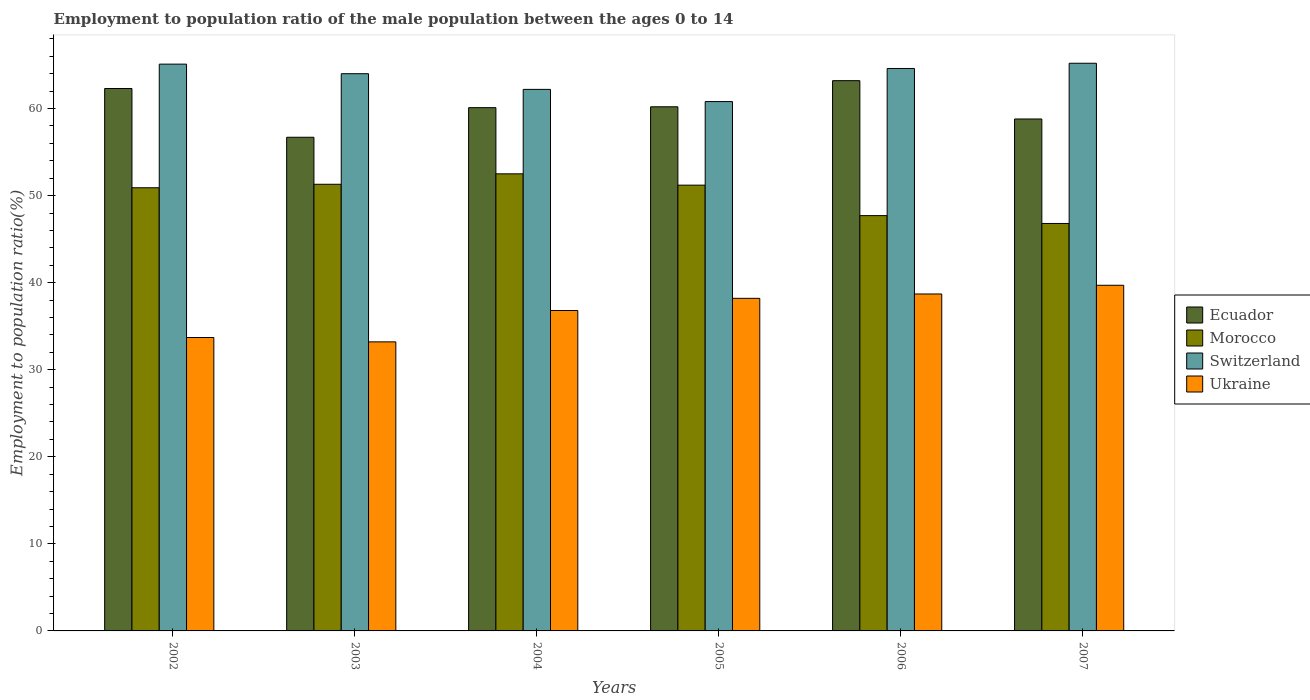How many different coloured bars are there?
Provide a succinct answer. 4. In how many cases, is the number of bars for a given year not equal to the number of legend labels?
Keep it short and to the point. 0. What is the employment to population ratio in Ecuador in 2005?
Keep it short and to the point. 60.2. Across all years, what is the maximum employment to population ratio in Morocco?
Your answer should be very brief. 52.5. Across all years, what is the minimum employment to population ratio in Morocco?
Ensure brevity in your answer.  46.8. In which year was the employment to population ratio in Ecuador maximum?
Offer a terse response. 2006. In which year was the employment to population ratio in Morocco minimum?
Ensure brevity in your answer.  2007. What is the total employment to population ratio in Switzerland in the graph?
Offer a very short reply. 381.9. What is the difference between the employment to population ratio in Switzerland in 2005 and that in 2007?
Make the answer very short. -4.4. What is the difference between the employment to population ratio in Ukraine in 2007 and the employment to population ratio in Switzerland in 2003?
Provide a short and direct response. -24.3. What is the average employment to population ratio in Morocco per year?
Give a very brief answer. 50.07. In the year 2003, what is the difference between the employment to population ratio in Ukraine and employment to population ratio in Morocco?
Your answer should be very brief. -18.1. In how many years, is the employment to population ratio in Switzerland greater than 18 %?
Offer a very short reply. 6. What is the ratio of the employment to population ratio in Switzerland in 2003 to that in 2006?
Keep it short and to the point. 0.99. Is the employment to population ratio in Morocco in 2002 less than that in 2006?
Make the answer very short. No. What is the difference between the highest and the second highest employment to population ratio in Ecuador?
Give a very brief answer. 0.9. What is the difference between the highest and the lowest employment to population ratio in Switzerland?
Ensure brevity in your answer.  4.4. Is the sum of the employment to population ratio in Morocco in 2003 and 2004 greater than the maximum employment to population ratio in Ukraine across all years?
Keep it short and to the point. Yes. What does the 3rd bar from the left in 2006 represents?
Make the answer very short. Switzerland. What does the 3rd bar from the right in 2003 represents?
Offer a terse response. Morocco. Is it the case that in every year, the sum of the employment to population ratio in Morocco and employment to population ratio in Ecuador is greater than the employment to population ratio in Switzerland?
Keep it short and to the point. Yes. What is the difference between two consecutive major ticks on the Y-axis?
Make the answer very short. 10. Are the values on the major ticks of Y-axis written in scientific E-notation?
Provide a succinct answer. No. Does the graph contain grids?
Offer a very short reply. No. Where does the legend appear in the graph?
Keep it short and to the point. Center right. How many legend labels are there?
Offer a terse response. 4. What is the title of the graph?
Give a very brief answer. Employment to population ratio of the male population between the ages 0 to 14. What is the label or title of the X-axis?
Offer a terse response. Years. What is the label or title of the Y-axis?
Your response must be concise. Employment to population ratio(%). What is the Employment to population ratio(%) of Ecuador in 2002?
Your answer should be compact. 62.3. What is the Employment to population ratio(%) of Morocco in 2002?
Offer a very short reply. 50.9. What is the Employment to population ratio(%) of Switzerland in 2002?
Provide a succinct answer. 65.1. What is the Employment to population ratio(%) in Ukraine in 2002?
Offer a terse response. 33.7. What is the Employment to population ratio(%) of Ecuador in 2003?
Provide a short and direct response. 56.7. What is the Employment to population ratio(%) in Morocco in 2003?
Make the answer very short. 51.3. What is the Employment to population ratio(%) in Ukraine in 2003?
Give a very brief answer. 33.2. What is the Employment to population ratio(%) in Ecuador in 2004?
Your answer should be compact. 60.1. What is the Employment to population ratio(%) in Morocco in 2004?
Your answer should be very brief. 52.5. What is the Employment to population ratio(%) in Switzerland in 2004?
Provide a succinct answer. 62.2. What is the Employment to population ratio(%) of Ukraine in 2004?
Give a very brief answer. 36.8. What is the Employment to population ratio(%) of Ecuador in 2005?
Provide a short and direct response. 60.2. What is the Employment to population ratio(%) in Morocco in 2005?
Your response must be concise. 51.2. What is the Employment to population ratio(%) of Switzerland in 2005?
Ensure brevity in your answer.  60.8. What is the Employment to population ratio(%) in Ukraine in 2005?
Your answer should be very brief. 38.2. What is the Employment to population ratio(%) of Ecuador in 2006?
Keep it short and to the point. 63.2. What is the Employment to population ratio(%) of Morocco in 2006?
Ensure brevity in your answer.  47.7. What is the Employment to population ratio(%) of Switzerland in 2006?
Give a very brief answer. 64.6. What is the Employment to population ratio(%) in Ukraine in 2006?
Give a very brief answer. 38.7. What is the Employment to population ratio(%) of Ecuador in 2007?
Make the answer very short. 58.8. What is the Employment to population ratio(%) in Morocco in 2007?
Offer a very short reply. 46.8. What is the Employment to population ratio(%) of Switzerland in 2007?
Your answer should be very brief. 65.2. What is the Employment to population ratio(%) in Ukraine in 2007?
Give a very brief answer. 39.7. Across all years, what is the maximum Employment to population ratio(%) of Ecuador?
Provide a succinct answer. 63.2. Across all years, what is the maximum Employment to population ratio(%) of Morocco?
Offer a very short reply. 52.5. Across all years, what is the maximum Employment to population ratio(%) of Switzerland?
Your response must be concise. 65.2. Across all years, what is the maximum Employment to population ratio(%) of Ukraine?
Offer a terse response. 39.7. Across all years, what is the minimum Employment to population ratio(%) in Ecuador?
Provide a succinct answer. 56.7. Across all years, what is the minimum Employment to population ratio(%) in Morocco?
Ensure brevity in your answer.  46.8. Across all years, what is the minimum Employment to population ratio(%) of Switzerland?
Offer a terse response. 60.8. Across all years, what is the minimum Employment to population ratio(%) of Ukraine?
Keep it short and to the point. 33.2. What is the total Employment to population ratio(%) in Ecuador in the graph?
Give a very brief answer. 361.3. What is the total Employment to population ratio(%) in Morocco in the graph?
Offer a very short reply. 300.4. What is the total Employment to population ratio(%) of Switzerland in the graph?
Give a very brief answer. 381.9. What is the total Employment to population ratio(%) in Ukraine in the graph?
Keep it short and to the point. 220.3. What is the difference between the Employment to population ratio(%) in Ecuador in 2002 and that in 2003?
Offer a terse response. 5.6. What is the difference between the Employment to population ratio(%) of Switzerland in 2002 and that in 2003?
Give a very brief answer. 1.1. What is the difference between the Employment to population ratio(%) in Ukraine in 2002 and that in 2003?
Your response must be concise. 0.5. What is the difference between the Employment to population ratio(%) of Ecuador in 2002 and that in 2004?
Give a very brief answer. 2.2. What is the difference between the Employment to population ratio(%) of Morocco in 2002 and that in 2004?
Offer a terse response. -1.6. What is the difference between the Employment to population ratio(%) of Switzerland in 2002 and that in 2004?
Keep it short and to the point. 2.9. What is the difference between the Employment to population ratio(%) in Ecuador in 2002 and that in 2005?
Provide a short and direct response. 2.1. What is the difference between the Employment to population ratio(%) in Ukraine in 2002 and that in 2005?
Your answer should be compact. -4.5. What is the difference between the Employment to population ratio(%) of Ecuador in 2002 and that in 2006?
Your answer should be compact. -0.9. What is the difference between the Employment to population ratio(%) of Ecuador in 2002 and that in 2007?
Provide a short and direct response. 3.5. What is the difference between the Employment to population ratio(%) in Morocco in 2002 and that in 2007?
Give a very brief answer. 4.1. What is the difference between the Employment to population ratio(%) in Ukraine in 2002 and that in 2007?
Keep it short and to the point. -6. What is the difference between the Employment to population ratio(%) of Ecuador in 2003 and that in 2004?
Offer a very short reply. -3.4. What is the difference between the Employment to population ratio(%) of Switzerland in 2003 and that in 2005?
Offer a very short reply. 3.2. What is the difference between the Employment to population ratio(%) of Switzerland in 2003 and that in 2006?
Give a very brief answer. -0.6. What is the difference between the Employment to population ratio(%) of Ecuador in 2003 and that in 2007?
Your answer should be very brief. -2.1. What is the difference between the Employment to population ratio(%) in Ukraine in 2004 and that in 2005?
Ensure brevity in your answer.  -1.4. What is the difference between the Employment to population ratio(%) of Ecuador in 2004 and that in 2006?
Provide a short and direct response. -3.1. What is the difference between the Employment to population ratio(%) of Morocco in 2004 and that in 2006?
Provide a succinct answer. 4.8. What is the difference between the Employment to population ratio(%) in Switzerland in 2004 and that in 2006?
Offer a terse response. -2.4. What is the difference between the Employment to population ratio(%) in Morocco in 2004 and that in 2007?
Your answer should be compact. 5.7. What is the difference between the Employment to population ratio(%) in Morocco in 2005 and that in 2006?
Your answer should be very brief. 3.5. What is the difference between the Employment to population ratio(%) of Ukraine in 2005 and that in 2006?
Offer a very short reply. -0.5. What is the difference between the Employment to population ratio(%) of Ecuador in 2005 and that in 2007?
Ensure brevity in your answer.  1.4. What is the difference between the Employment to population ratio(%) of Ukraine in 2005 and that in 2007?
Ensure brevity in your answer.  -1.5. What is the difference between the Employment to population ratio(%) of Ecuador in 2006 and that in 2007?
Ensure brevity in your answer.  4.4. What is the difference between the Employment to population ratio(%) of Morocco in 2006 and that in 2007?
Your answer should be very brief. 0.9. What is the difference between the Employment to population ratio(%) of Ecuador in 2002 and the Employment to population ratio(%) of Morocco in 2003?
Keep it short and to the point. 11. What is the difference between the Employment to population ratio(%) in Ecuador in 2002 and the Employment to population ratio(%) in Ukraine in 2003?
Your answer should be compact. 29.1. What is the difference between the Employment to population ratio(%) in Morocco in 2002 and the Employment to population ratio(%) in Ukraine in 2003?
Give a very brief answer. 17.7. What is the difference between the Employment to population ratio(%) of Switzerland in 2002 and the Employment to population ratio(%) of Ukraine in 2003?
Your answer should be very brief. 31.9. What is the difference between the Employment to population ratio(%) in Ecuador in 2002 and the Employment to population ratio(%) in Switzerland in 2004?
Provide a succinct answer. 0.1. What is the difference between the Employment to population ratio(%) in Ecuador in 2002 and the Employment to population ratio(%) in Ukraine in 2004?
Provide a succinct answer. 25.5. What is the difference between the Employment to population ratio(%) of Morocco in 2002 and the Employment to population ratio(%) of Ukraine in 2004?
Make the answer very short. 14.1. What is the difference between the Employment to population ratio(%) of Switzerland in 2002 and the Employment to population ratio(%) of Ukraine in 2004?
Provide a short and direct response. 28.3. What is the difference between the Employment to population ratio(%) in Ecuador in 2002 and the Employment to population ratio(%) in Switzerland in 2005?
Your answer should be very brief. 1.5. What is the difference between the Employment to population ratio(%) of Ecuador in 2002 and the Employment to population ratio(%) of Ukraine in 2005?
Keep it short and to the point. 24.1. What is the difference between the Employment to population ratio(%) of Morocco in 2002 and the Employment to population ratio(%) of Switzerland in 2005?
Ensure brevity in your answer.  -9.9. What is the difference between the Employment to population ratio(%) of Morocco in 2002 and the Employment to population ratio(%) of Ukraine in 2005?
Your answer should be compact. 12.7. What is the difference between the Employment to population ratio(%) in Switzerland in 2002 and the Employment to population ratio(%) in Ukraine in 2005?
Give a very brief answer. 26.9. What is the difference between the Employment to population ratio(%) in Ecuador in 2002 and the Employment to population ratio(%) in Switzerland in 2006?
Make the answer very short. -2.3. What is the difference between the Employment to population ratio(%) of Ecuador in 2002 and the Employment to population ratio(%) of Ukraine in 2006?
Offer a very short reply. 23.6. What is the difference between the Employment to population ratio(%) in Morocco in 2002 and the Employment to population ratio(%) in Switzerland in 2006?
Ensure brevity in your answer.  -13.7. What is the difference between the Employment to population ratio(%) of Switzerland in 2002 and the Employment to population ratio(%) of Ukraine in 2006?
Offer a terse response. 26.4. What is the difference between the Employment to population ratio(%) of Ecuador in 2002 and the Employment to population ratio(%) of Switzerland in 2007?
Your answer should be compact. -2.9. What is the difference between the Employment to population ratio(%) in Ecuador in 2002 and the Employment to population ratio(%) in Ukraine in 2007?
Your answer should be compact. 22.6. What is the difference between the Employment to population ratio(%) of Morocco in 2002 and the Employment to population ratio(%) of Switzerland in 2007?
Your response must be concise. -14.3. What is the difference between the Employment to population ratio(%) in Switzerland in 2002 and the Employment to population ratio(%) in Ukraine in 2007?
Your answer should be very brief. 25.4. What is the difference between the Employment to population ratio(%) of Ecuador in 2003 and the Employment to population ratio(%) of Ukraine in 2004?
Provide a short and direct response. 19.9. What is the difference between the Employment to population ratio(%) of Morocco in 2003 and the Employment to population ratio(%) of Ukraine in 2004?
Keep it short and to the point. 14.5. What is the difference between the Employment to population ratio(%) in Switzerland in 2003 and the Employment to population ratio(%) in Ukraine in 2004?
Provide a succinct answer. 27.2. What is the difference between the Employment to population ratio(%) in Ecuador in 2003 and the Employment to population ratio(%) in Morocco in 2005?
Ensure brevity in your answer.  5.5. What is the difference between the Employment to population ratio(%) of Ecuador in 2003 and the Employment to population ratio(%) of Ukraine in 2005?
Give a very brief answer. 18.5. What is the difference between the Employment to population ratio(%) in Morocco in 2003 and the Employment to population ratio(%) in Switzerland in 2005?
Offer a terse response. -9.5. What is the difference between the Employment to population ratio(%) of Morocco in 2003 and the Employment to population ratio(%) of Ukraine in 2005?
Offer a terse response. 13.1. What is the difference between the Employment to population ratio(%) in Switzerland in 2003 and the Employment to population ratio(%) in Ukraine in 2005?
Your answer should be compact. 25.8. What is the difference between the Employment to population ratio(%) in Ecuador in 2003 and the Employment to population ratio(%) in Switzerland in 2006?
Your answer should be very brief. -7.9. What is the difference between the Employment to population ratio(%) in Ecuador in 2003 and the Employment to population ratio(%) in Ukraine in 2006?
Provide a succinct answer. 18. What is the difference between the Employment to population ratio(%) of Morocco in 2003 and the Employment to population ratio(%) of Switzerland in 2006?
Your answer should be very brief. -13.3. What is the difference between the Employment to population ratio(%) in Switzerland in 2003 and the Employment to population ratio(%) in Ukraine in 2006?
Provide a short and direct response. 25.3. What is the difference between the Employment to population ratio(%) of Morocco in 2003 and the Employment to population ratio(%) of Switzerland in 2007?
Offer a terse response. -13.9. What is the difference between the Employment to population ratio(%) of Switzerland in 2003 and the Employment to population ratio(%) of Ukraine in 2007?
Your answer should be compact. 24.3. What is the difference between the Employment to population ratio(%) in Ecuador in 2004 and the Employment to population ratio(%) in Ukraine in 2005?
Keep it short and to the point. 21.9. What is the difference between the Employment to population ratio(%) of Switzerland in 2004 and the Employment to population ratio(%) of Ukraine in 2005?
Give a very brief answer. 24. What is the difference between the Employment to population ratio(%) of Ecuador in 2004 and the Employment to population ratio(%) of Morocco in 2006?
Make the answer very short. 12.4. What is the difference between the Employment to population ratio(%) in Ecuador in 2004 and the Employment to population ratio(%) in Ukraine in 2006?
Your answer should be very brief. 21.4. What is the difference between the Employment to population ratio(%) of Switzerland in 2004 and the Employment to population ratio(%) of Ukraine in 2006?
Your answer should be very brief. 23.5. What is the difference between the Employment to population ratio(%) in Ecuador in 2004 and the Employment to population ratio(%) in Ukraine in 2007?
Provide a succinct answer. 20.4. What is the difference between the Employment to population ratio(%) of Switzerland in 2004 and the Employment to population ratio(%) of Ukraine in 2007?
Keep it short and to the point. 22.5. What is the difference between the Employment to population ratio(%) of Morocco in 2005 and the Employment to population ratio(%) of Switzerland in 2006?
Your answer should be compact. -13.4. What is the difference between the Employment to population ratio(%) of Morocco in 2005 and the Employment to population ratio(%) of Ukraine in 2006?
Provide a short and direct response. 12.5. What is the difference between the Employment to population ratio(%) in Switzerland in 2005 and the Employment to population ratio(%) in Ukraine in 2006?
Provide a short and direct response. 22.1. What is the difference between the Employment to population ratio(%) in Ecuador in 2005 and the Employment to population ratio(%) in Morocco in 2007?
Your answer should be compact. 13.4. What is the difference between the Employment to population ratio(%) in Ecuador in 2005 and the Employment to population ratio(%) in Switzerland in 2007?
Your answer should be compact. -5. What is the difference between the Employment to population ratio(%) of Morocco in 2005 and the Employment to population ratio(%) of Ukraine in 2007?
Your response must be concise. 11.5. What is the difference between the Employment to population ratio(%) in Switzerland in 2005 and the Employment to population ratio(%) in Ukraine in 2007?
Make the answer very short. 21.1. What is the difference between the Employment to population ratio(%) of Morocco in 2006 and the Employment to population ratio(%) of Switzerland in 2007?
Your answer should be very brief. -17.5. What is the difference between the Employment to population ratio(%) in Morocco in 2006 and the Employment to population ratio(%) in Ukraine in 2007?
Your answer should be very brief. 8. What is the difference between the Employment to population ratio(%) in Switzerland in 2006 and the Employment to population ratio(%) in Ukraine in 2007?
Provide a succinct answer. 24.9. What is the average Employment to population ratio(%) in Ecuador per year?
Offer a very short reply. 60.22. What is the average Employment to population ratio(%) of Morocco per year?
Your response must be concise. 50.07. What is the average Employment to population ratio(%) in Switzerland per year?
Provide a short and direct response. 63.65. What is the average Employment to population ratio(%) in Ukraine per year?
Offer a very short reply. 36.72. In the year 2002, what is the difference between the Employment to population ratio(%) of Ecuador and Employment to population ratio(%) of Switzerland?
Provide a succinct answer. -2.8. In the year 2002, what is the difference between the Employment to population ratio(%) of Ecuador and Employment to population ratio(%) of Ukraine?
Your answer should be compact. 28.6. In the year 2002, what is the difference between the Employment to population ratio(%) of Morocco and Employment to population ratio(%) of Switzerland?
Your answer should be very brief. -14.2. In the year 2002, what is the difference between the Employment to population ratio(%) in Morocco and Employment to population ratio(%) in Ukraine?
Give a very brief answer. 17.2. In the year 2002, what is the difference between the Employment to population ratio(%) of Switzerland and Employment to population ratio(%) of Ukraine?
Your answer should be very brief. 31.4. In the year 2003, what is the difference between the Employment to population ratio(%) in Ecuador and Employment to population ratio(%) in Morocco?
Offer a terse response. 5.4. In the year 2003, what is the difference between the Employment to population ratio(%) in Ecuador and Employment to population ratio(%) in Ukraine?
Provide a short and direct response. 23.5. In the year 2003, what is the difference between the Employment to population ratio(%) in Morocco and Employment to population ratio(%) in Switzerland?
Offer a very short reply. -12.7. In the year 2003, what is the difference between the Employment to population ratio(%) in Switzerland and Employment to population ratio(%) in Ukraine?
Keep it short and to the point. 30.8. In the year 2004, what is the difference between the Employment to population ratio(%) of Ecuador and Employment to population ratio(%) of Morocco?
Ensure brevity in your answer.  7.6. In the year 2004, what is the difference between the Employment to population ratio(%) in Ecuador and Employment to population ratio(%) in Ukraine?
Offer a very short reply. 23.3. In the year 2004, what is the difference between the Employment to population ratio(%) of Morocco and Employment to population ratio(%) of Ukraine?
Provide a short and direct response. 15.7. In the year 2004, what is the difference between the Employment to population ratio(%) of Switzerland and Employment to population ratio(%) of Ukraine?
Your response must be concise. 25.4. In the year 2005, what is the difference between the Employment to population ratio(%) in Ecuador and Employment to population ratio(%) in Switzerland?
Ensure brevity in your answer.  -0.6. In the year 2005, what is the difference between the Employment to population ratio(%) in Ecuador and Employment to population ratio(%) in Ukraine?
Give a very brief answer. 22. In the year 2005, what is the difference between the Employment to population ratio(%) in Morocco and Employment to population ratio(%) in Ukraine?
Your answer should be compact. 13. In the year 2005, what is the difference between the Employment to population ratio(%) in Switzerland and Employment to population ratio(%) in Ukraine?
Offer a terse response. 22.6. In the year 2006, what is the difference between the Employment to population ratio(%) of Ecuador and Employment to population ratio(%) of Switzerland?
Your answer should be compact. -1.4. In the year 2006, what is the difference between the Employment to population ratio(%) of Ecuador and Employment to population ratio(%) of Ukraine?
Give a very brief answer. 24.5. In the year 2006, what is the difference between the Employment to population ratio(%) in Morocco and Employment to population ratio(%) in Switzerland?
Offer a very short reply. -16.9. In the year 2006, what is the difference between the Employment to population ratio(%) in Morocco and Employment to population ratio(%) in Ukraine?
Provide a succinct answer. 9. In the year 2006, what is the difference between the Employment to population ratio(%) in Switzerland and Employment to population ratio(%) in Ukraine?
Keep it short and to the point. 25.9. In the year 2007, what is the difference between the Employment to population ratio(%) in Ecuador and Employment to population ratio(%) in Morocco?
Your answer should be compact. 12. In the year 2007, what is the difference between the Employment to population ratio(%) of Ecuador and Employment to population ratio(%) of Switzerland?
Give a very brief answer. -6.4. In the year 2007, what is the difference between the Employment to population ratio(%) in Morocco and Employment to population ratio(%) in Switzerland?
Offer a very short reply. -18.4. What is the ratio of the Employment to population ratio(%) in Ecuador in 2002 to that in 2003?
Your answer should be very brief. 1.1. What is the ratio of the Employment to population ratio(%) of Switzerland in 2002 to that in 2003?
Offer a very short reply. 1.02. What is the ratio of the Employment to population ratio(%) of Ukraine in 2002 to that in 2003?
Offer a terse response. 1.02. What is the ratio of the Employment to population ratio(%) in Ecuador in 2002 to that in 2004?
Make the answer very short. 1.04. What is the ratio of the Employment to population ratio(%) of Morocco in 2002 to that in 2004?
Offer a very short reply. 0.97. What is the ratio of the Employment to population ratio(%) of Switzerland in 2002 to that in 2004?
Offer a terse response. 1.05. What is the ratio of the Employment to population ratio(%) in Ukraine in 2002 to that in 2004?
Give a very brief answer. 0.92. What is the ratio of the Employment to population ratio(%) of Ecuador in 2002 to that in 2005?
Give a very brief answer. 1.03. What is the ratio of the Employment to population ratio(%) of Morocco in 2002 to that in 2005?
Make the answer very short. 0.99. What is the ratio of the Employment to population ratio(%) of Switzerland in 2002 to that in 2005?
Provide a short and direct response. 1.07. What is the ratio of the Employment to population ratio(%) in Ukraine in 2002 to that in 2005?
Your answer should be very brief. 0.88. What is the ratio of the Employment to population ratio(%) of Ecuador in 2002 to that in 2006?
Give a very brief answer. 0.99. What is the ratio of the Employment to population ratio(%) in Morocco in 2002 to that in 2006?
Offer a very short reply. 1.07. What is the ratio of the Employment to population ratio(%) of Switzerland in 2002 to that in 2006?
Your answer should be compact. 1.01. What is the ratio of the Employment to population ratio(%) of Ukraine in 2002 to that in 2006?
Keep it short and to the point. 0.87. What is the ratio of the Employment to population ratio(%) of Ecuador in 2002 to that in 2007?
Give a very brief answer. 1.06. What is the ratio of the Employment to population ratio(%) of Morocco in 2002 to that in 2007?
Provide a succinct answer. 1.09. What is the ratio of the Employment to population ratio(%) in Ukraine in 2002 to that in 2007?
Offer a terse response. 0.85. What is the ratio of the Employment to population ratio(%) in Ecuador in 2003 to that in 2004?
Make the answer very short. 0.94. What is the ratio of the Employment to population ratio(%) in Morocco in 2003 to that in 2004?
Offer a very short reply. 0.98. What is the ratio of the Employment to population ratio(%) in Switzerland in 2003 to that in 2004?
Give a very brief answer. 1.03. What is the ratio of the Employment to population ratio(%) in Ukraine in 2003 to that in 2004?
Give a very brief answer. 0.9. What is the ratio of the Employment to population ratio(%) in Ecuador in 2003 to that in 2005?
Provide a short and direct response. 0.94. What is the ratio of the Employment to population ratio(%) in Switzerland in 2003 to that in 2005?
Provide a succinct answer. 1.05. What is the ratio of the Employment to population ratio(%) of Ukraine in 2003 to that in 2005?
Provide a succinct answer. 0.87. What is the ratio of the Employment to population ratio(%) in Ecuador in 2003 to that in 2006?
Offer a terse response. 0.9. What is the ratio of the Employment to population ratio(%) of Morocco in 2003 to that in 2006?
Offer a very short reply. 1.08. What is the ratio of the Employment to population ratio(%) of Switzerland in 2003 to that in 2006?
Keep it short and to the point. 0.99. What is the ratio of the Employment to population ratio(%) of Ukraine in 2003 to that in 2006?
Give a very brief answer. 0.86. What is the ratio of the Employment to population ratio(%) in Ecuador in 2003 to that in 2007?
Your answer should be compact. 0.96. What is the ratio of the Employment to population ratio(%) in Morocco in 2003 to that in 2007?
Provide a succinct answer. 1.1. What is the ratio of the Employment to population ratio(%) in Switzerland in 2003 to that in 2007?
Your answer should be compact. 0.98. What is the ratio of the Employment to population ratio(%) of Ukraine in 2003 to that in 2007?
Make the answer very short. 0.84. What is the ratio of the Employment to population ratio(%) in Morocco in 2004 to that in 2005?
Your answer should be very brief. 1.03. What is the ratio of the Employment to population ratio(%) of Switzerland in 2004 to that in 2005?
Give a very brief answer. 1.02. What is the ratio of the Employment to population ratio(%) in Ukraine in 2004 to that in 2005?
Ensure brevity in your answer.  0.96. What is the ratio of the Employment to population ratio(%) of Ecuador in 2004 to that in 2006?
Give a very brief answer. 0.95. What is the ratio of the Employment to population ratio(%) of Morocco in 2004 to that in 2006?
Make the answer very short. 1.1. What is the ratio of the Employment to population ratio(%) in Switzerland in 2004 to that in 2006?
Offer a very short reply. 0.96. What is the ratio of the Employment to population ratio(%) in Ukraine in 2004 to that in 2006?
Offer a terse response. 0.95. What is the ratio of the Employment to population ratio(%) in Ecuador in 2004 to that in 2007?
Keep it short and to the point. 1.02. What is the ratio of the Employment to population ratio(%) in Morocco in 2004 to that in 2007?
Make the answer very short. 1.12. What is the ratio of the Employment to population ratio(%) in Switzerland in 2004 to that in 2007?
Make the answer very short. 0.95. What is the ratio of the Employment to population ratio(%) of Ukraine in 2004 to that in 2007?
Make the answer very short. 0.93. What is the ratio of the Employment to population ratio(%) of Ecuador in 2005 to that in 2006?
Offer a terse response. 0.95. What is the ratio of the Employment to population ratio(%) in Morocco in 2005 to that in 2006?
Your answer should be compact. 1.07. What is the ratio of the Employment to population ratio(%) in Ukraine in 2005 to that in 2006?
Offer a very short reply. 0.99. What is the ratio of the Employment to population ratio(%) of Ecuador in 2005 to that in 2007?
Keep it short and to the point. 1.02. What is the ratio of the Employment to population ratio(%) of Morocco in 2005 to that in 2007?
Provide a succinct answer. 1.09. What is the ratio of the Employment to population ratio(%) in Switzerland in 2005 to that in 2007?
Offer a terse response. 0.93. What is the ratio of the Employment to population ratio(%) in Ukraine in 2005 to that in 2007?
Ensure brevity in your answer.  0.96. What is the ratio of the Employment to population ratio(%) in Ecuador in 2006 to that in 2007?
Ensure brevity in your answer.  1.07. What is the ratio of the Employment to population ratio(%) of Morocco in 2006 to that in 2007?
Your answer should be very brief. 1.02. What is the ratio of the Employment to population ratio(%) in Ukraine in 2006 to that in 2007?
Your answer should be very brief. 0.97. What is the difference between the highest and the second highest Employment to population ratio(%) of Morocco?
Provide a short and direct response. 1.2. What is the difference between the highest and the second highest Employment to population ratio(%) of Ukraine?
Your answer should be compact. 1. What is the difference between the highest and the lowest Employment to population ratio(%) of Ecuador?
Make the answer very short. 6.5. What is the difference between the highest and the lowest Employment to population ratio(%) in Morocco?
Offer a very short reply. 5.7. What is the difference between the highest and the lowest Employment to population ratio(%) of Switzerland?
Your answer should be very brief. 4.4. What is the difference between the highest and the lowest Employment to population ratio(%) in Ukraine?
Keep it short and to the point. 6.5. 